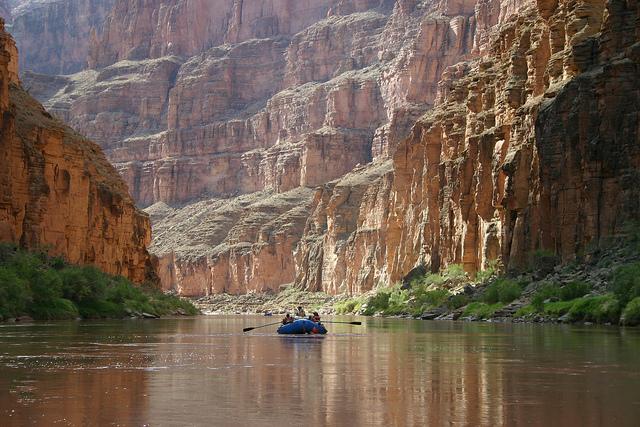What is on the side walls of the canyon?
Give a very brief answer. Rocks. Does this look like the Grand Canyon?
Answer briefly. Yes. What kind of boat is in the water?
Give a very brief answer. Raft. 